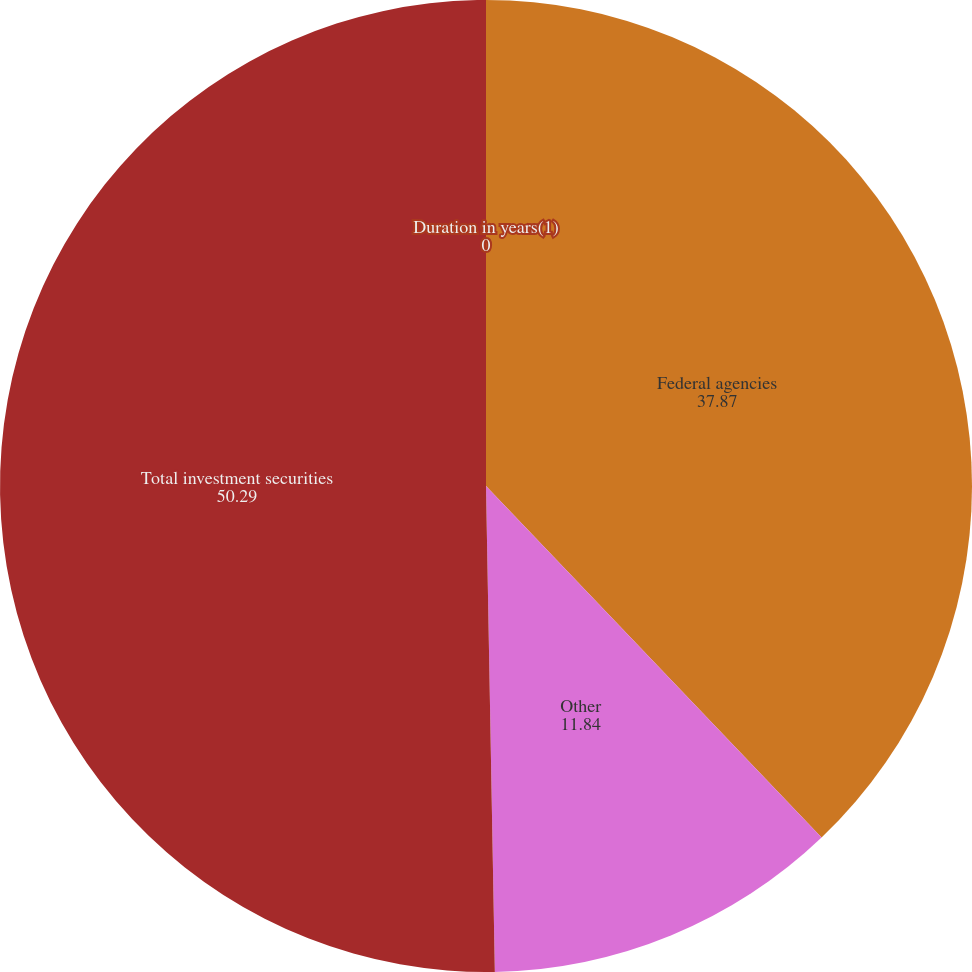Convert chart to OTSL. <chart><loc_0><loc_0><loc_500><loc_500><pie_chart><fcel>Federal agencies<fcel>Other<fcel>Total investment securities<fcel>Duration in years(1)<nl><fcel>37.87%<fcel>11.84%<fcel>50.29%<fcel>0.0%<nl></chart> 